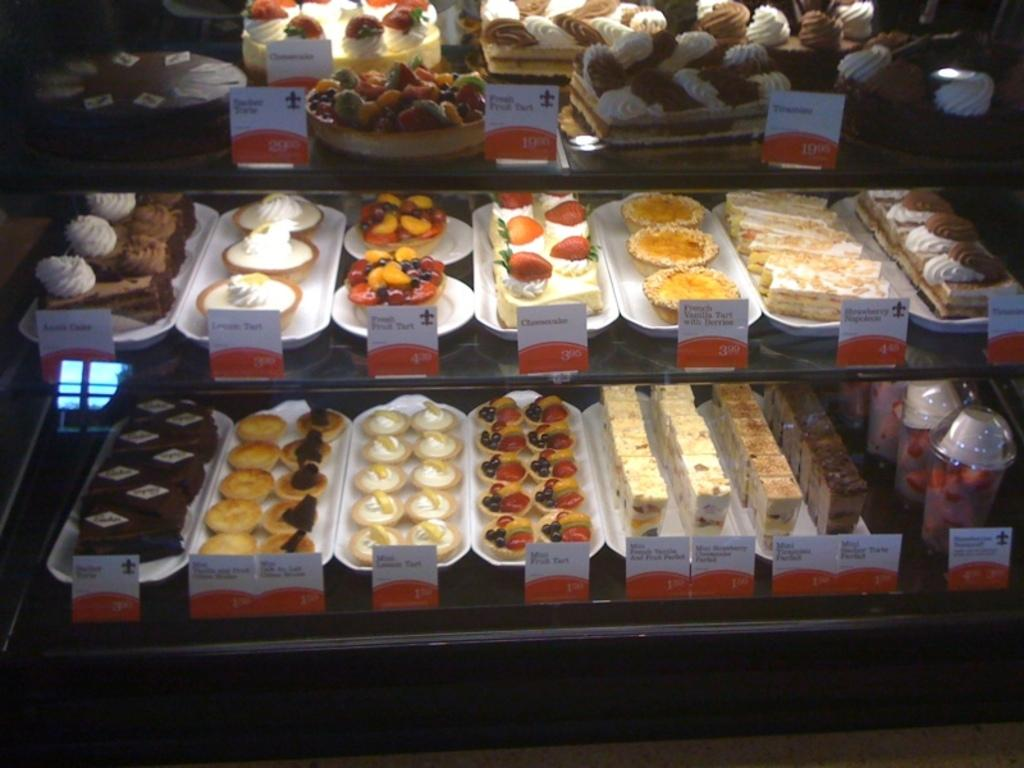What type of food can be seen in the image? There are cakes and baked food in the image. How are the food items arranged in the image? The food items are arranged in a rack in the image. What type of government is depicted in the image? There is no government depicted in the image; it features cakes and baked food arranged in a rack. 